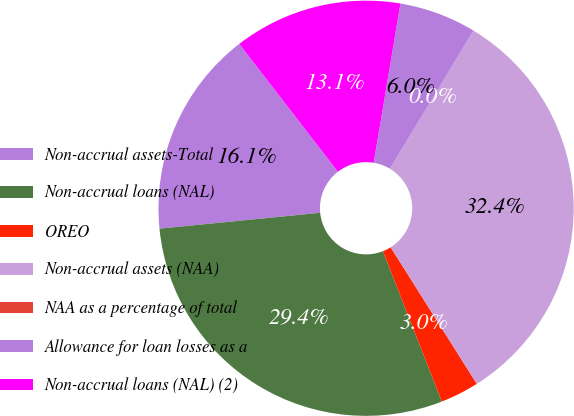Convert chart. <chart><loc_0><loc_0><loc_500><loc_500><pie_chart><fcel>Non-accrual assets-Total<fcel>Non-accrual loans (NAL)<fcel>OREO<fcel>Non-accrual assets (NAA)<fcel>NAA as a percentage of total<fcel>Allowance for loan losses as a<fcel>Non-accrual loans (NAL) (2)<nl><fcel>16.11%<fcel>29.38%<fcel>3.01%<fcel>32.39%<fcel>0.0%<fcel>6.01%<fcel>13.11%<nl></chart> 